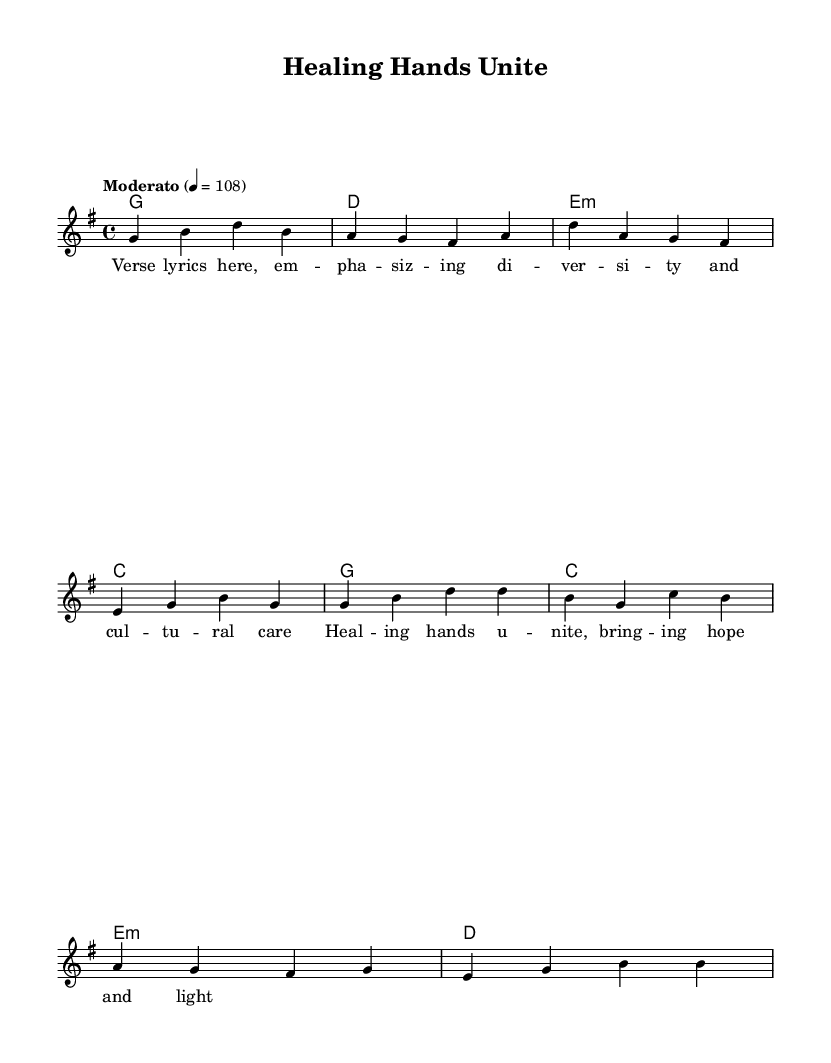What is the key signature of this music? The key signature is G major, which has one sharp (F#). This can be identified by looking at the key signature indication at the beginning of the sheet music.
Answer: G major What is the time signature of this music? The time signature is 4/4, which means there are four beats in each measure and a quarter note represents one beat. This is indicated directly in the sheet music.
Answer: 4/4 What is the tempo marking for the piece? The tempo marking is Moderato, which indicates a moderate speed, and the number 108 indicates the number of beats per minute. It's shown near the beginning of the score.
Answer: Moderato How many measures are in the verse? The verse contains four measures, which can be counted by observing the music notation. Each group of notes separated by vertical lines represents one measure, and there are four such groups in the verse segment.
Answer: Four What chords are used in the chorus? The chords used in the chorus are G, C, E minor, and D. This can be determined by looking at the chord names shown above the melody line in the chorus section of the sheet music.
Answer: G, C, E minor, D What is the last line of the chorus lyrics? The last line of the chorus lyrics is "bringing hope and light." This can be found by examining the lyrics aligned with the melody in the chorus section of the sheet music.
Answer: bringing hope and light How do the lyrics of the verse relate to the theme of the song? The lyrics of the verse emphasize diversity and cultural care, reflecting the theme of unity in healthcare. This is derived from the emphasis on "diversity" in the placeholder lyrics, implying the song's message about the importance of inclusive care.
Answer: Diversity and cultural care 